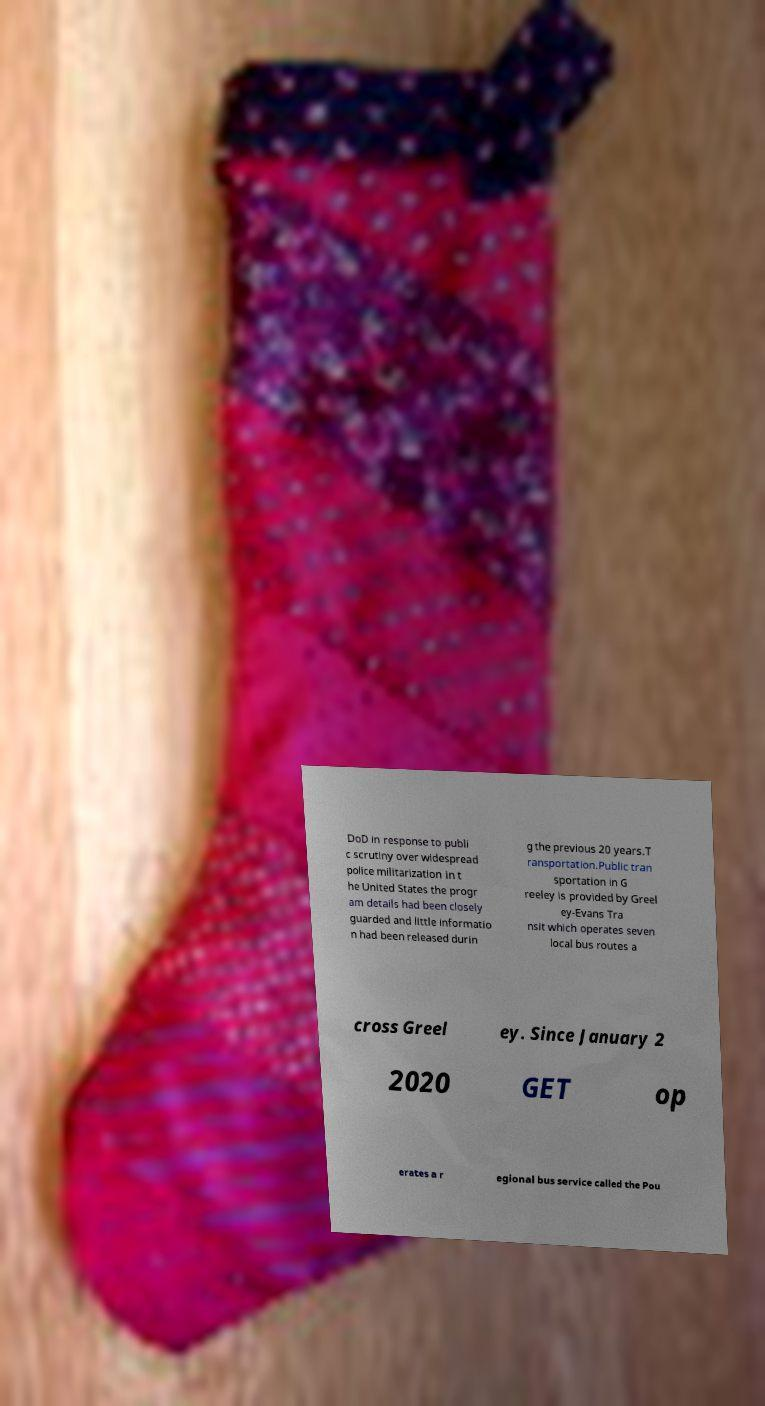Could you assist in decoding the text presented in this image and type it out clearly? DoD in response to publi c scrutiny over widespread police militarization in t he United States the progr am details had been closely guarded and little informatio n had been released durin g the previous 20 years.T ransportation.Public tran sportation in G reeley is provided by Greel ey-Evans Tra nsit which operates seven local bus routes a cross Greel ey. Since January 2 2020 GET op erates a r egional bus service called the Pou 